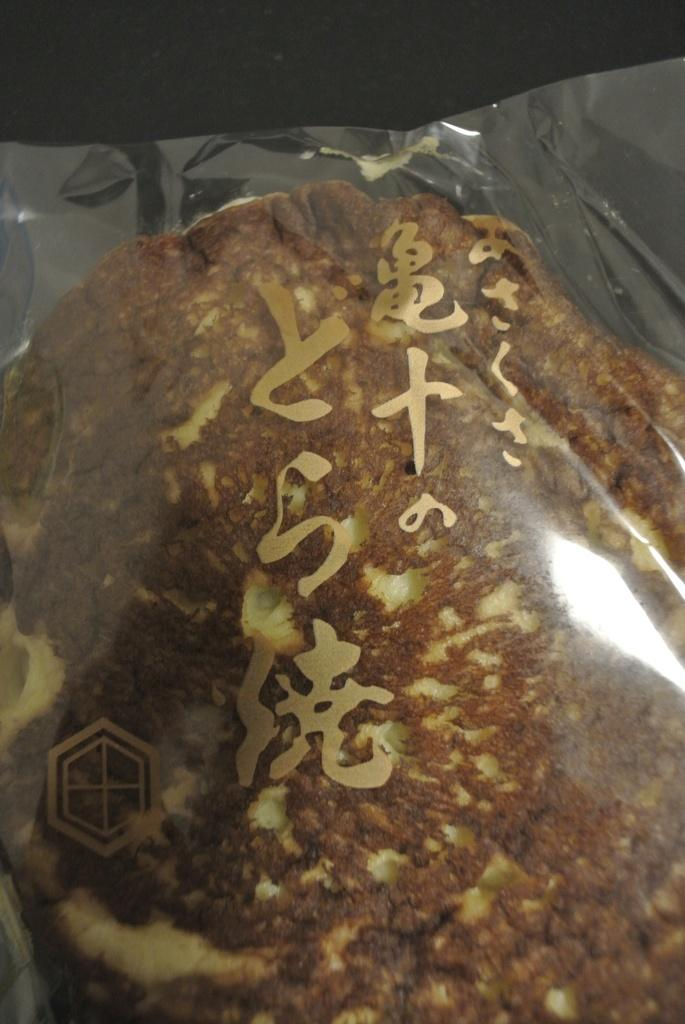What is the main subject of the image? There is a food item in the image. How is the food item protected or preserved? The food item is covered in a plastic cover. What color is the background of the image? The background of the image is black. How many giants are visible in the image? There are no giants present in the image. What does the mom say about the food item in the image? There is no reference to a mom or any dialogue in the image, so it cannot be determined what she might say about the food item. 